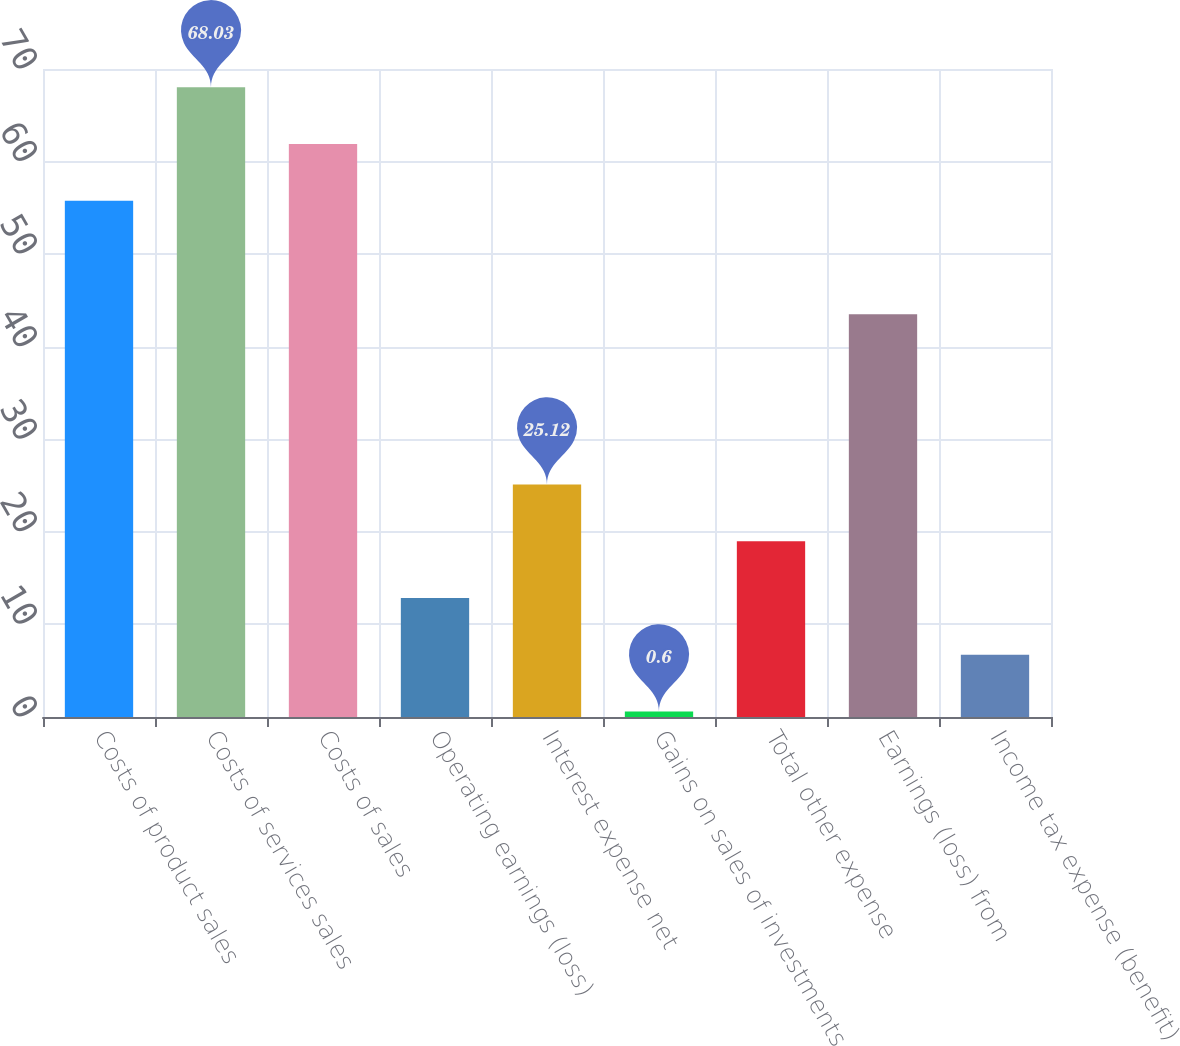Convert chart to OTSL. <chart><loc_0><loc_0><loc_500><loc_500><bar_chart><fcel>Costs of product sales<fcel>Costs of services sales<fcel>Costs of sales<fcel>Operating earnings (loss)<fcel>Interest expense net<fcel>Gains on sales of investments<fcel>Total other expense<fcel>Earnings (loss) from<fcel>Income tax expense (benefit)<nl><fcel>55.77<fcel>68.03<fcel>61.9<fcel>12.86<fcel>25.12<fcel>0.6<fcel>18.99<fcel>43.51<fcel>6.73<nl></chart> 